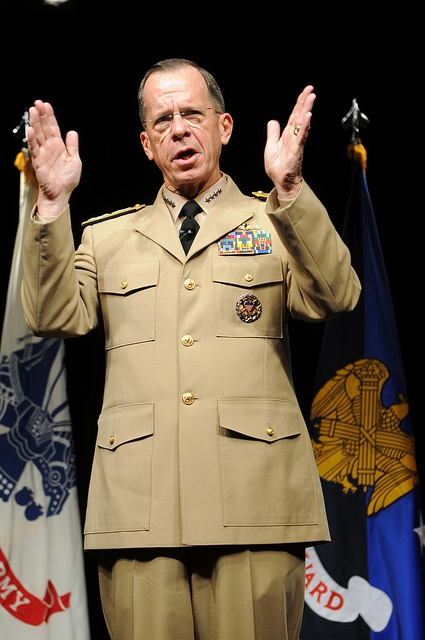Describe the objects in this image and their specific colors. I can see people in black and tan tones and tie in black, gray, and tan tones in this image. 